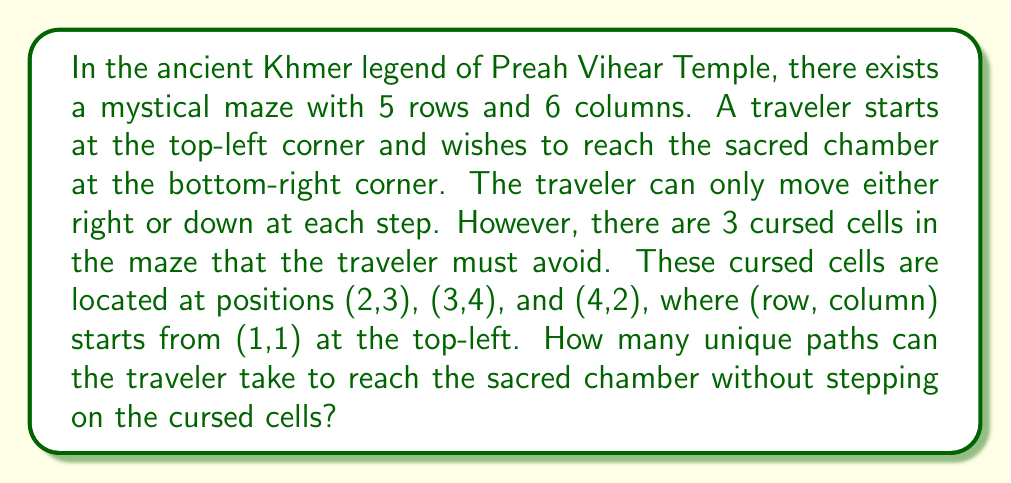Solve this math problem. Let's approach this step-by-step:

1) First, let's visualize the maze:

[asy]
unitsize(1cm);
for(int i=0; i<=5; ++i) draw((0,i)--(6,i));
for(int j=0; j<=6; ++j) draw((j,0)--(j,5));
fill((2,3)--cycle,red);
fill((3,2)--cycle,red);
fill((1,4)--cycle,red);
label("S",(0,5),W);
label("E",(6,0),E);
[/asy]

2) We can use dynamic programming to solve this. Let's create a 5x6 grid $dp$ where $dp[i][j]$ represents the number of unique paths to cell $(i,j)$.

3) Initialize the first row and column:
   - For the first row: $dp[0][j] = 1$ for all $j$, except for cursed cells.
   - For the first column: $dp[i][0] = 1$ for all $i$.

4) For other cells, we use the recurrence relation:
   $dp[i][j] = dp[i-1][j] + dp[i][j-1]$, unless $(i,j)$ is a cursed cell.

5) Fill the $dp$ grid:

$$
\begin{array}{c|cccccc}
  & 1 & 2 & 3 & 4 & 5 & 6 \\
\hline
1 & 1 & 1 & 1 & 1 & 1 & 1 \\
2 & 1 & 2 & 0 & 3 & 4 & 5 \\
3 & 1 & 3 & 3 & 0 & 4 & 9 \\
4 & 1 & 0 & 3 & 3 & 7 & 16 \\
5 & 1 & 1 & 4 & 7 & 14 & 30
\end{array}
$$

6) The bottom-right cell $dp[4][5] = 30$ gives us the total number of unique paths.
Answer: 30 